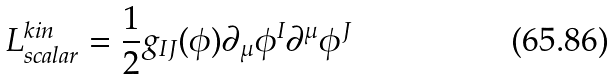Convert formula to latex. <formula><loc_0><loc_0><loc_500><loc_500>L _ { s c a l a r } ^ { k i n } = \frac { 1 } { 2 } g _ { I J } ( \phi ) \partial _ { \mu } \phi ^ { I } \partial ^ { \mu } \phi ^ { J }</formula> 